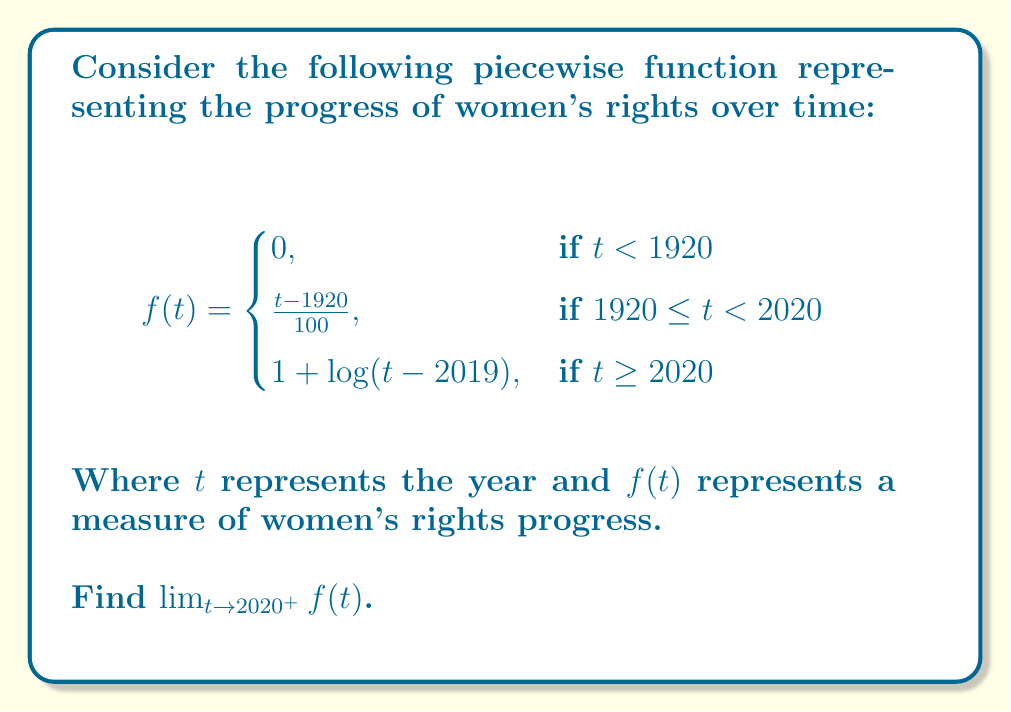Solve this math problem. To find $\lim_{t \to 2020^+} f(t)$, we need to evaluate the limit as $t$ approaches 2020 from the right side. This means we'll be using the third piece of the function:

$$f(t) = 1 + \log(t - 2019) \quad \text{for } t \geq 2020$$

Let's approach this step-by-step:

1) As $t$ approaches 2020 from the right, $(t - 2019)$ approaches 1.

2) We can express this limit as:
   $$\lim_{t \to 2020^+} f(t) = \lim_{t \to 2020^+} [1 + \log(t - 2019)]$$

3) Using the limit laws, we can separate this into:
   $$\lim_{t \to 2020^+} 1 + \lim_{t \to 2020^+} \log(t - 2019)$$

4) The limit of a constant is the constant itself, so:
   $$1 + \lim_{t \to 2020^+} \log(t - 2019)$$

5) Now, as $t \to 2020^+$, $(t - 2019) \to 1^+$

6) We know that $\log(1) = 0$, so:
   $$1 + \lim_{t \to 2020^+} \log(t - 2019) = 1 + 0 = 1$$

Therefore, $\lim_{t \to 2020^+} f(t) = 1$.

This result symbolizes that as we approach the year 2020 from the future, the measure of women's rights progress approaches 1, representing significant advancement but also acknowledging the ongoing nature of the struggle for full equality.
Answer: $1$ 